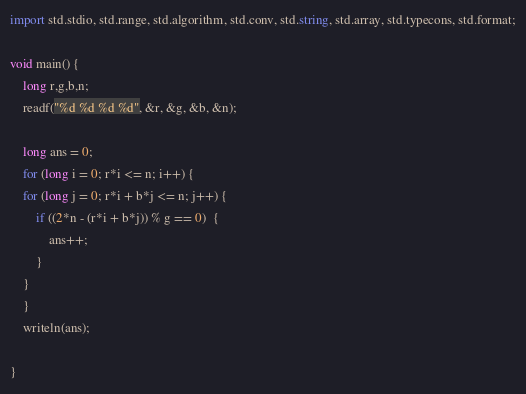<code> <loc_0><loc_0><loc_500><loc_500><_D_>import std.stdio, std.range, std.algorithm, std.conv, std.string, std.array, std.typecons, std.format;

void main() {
    long r,g,b,n;
    readf("%d %d %d %d", &r, &g, &b, &n);

    long ans = 0;
    for (long i = 0; r*i <= n; i++) {
    for (long j = 0; r*i + b*j <= n; j++) {
        if ((2*n - (r*i + b*j)) % g == 0)  {
            ans++;
        }
    }
    }
    writeln(ans);

}
</code> 